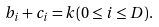<formula> <loc_0><loc_0><loc_500><loc_500>b _ { i } + c _ { i } = k ( 0 \leq i \leq D ) .</formula> 